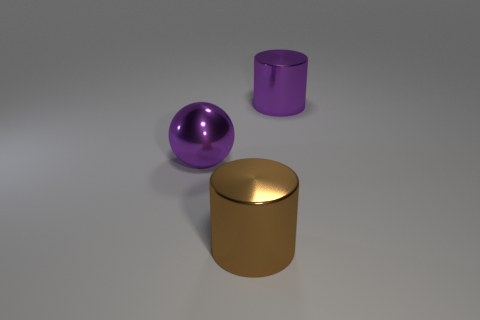What number of brown metal things have the same size as the shiny sphere?
Provide a succinct answer. 1. The large purple object that is made of the same material as the purple cylinder is what shape?
Your response must be concise. Sphere. Are there any metal cylinders of the same color as the sphere?
Your answer should be compact. Yes. What is the brown thing made of?
Provide a succinct answer. Metal. What number of things are either large purple metal balls or purple shiny cylinders?
Ensure brevity in your answer.  2. There is a thing that is in front of the large ball; what is its size?
Make the answer very short. Large. What number of other things are the same material as the big sphere?
Ensure brevity in your answer.  2. There is a metal object in front of the purple shiny ball; is there a big metal cylinder left of it?
Provide a short and direct response. No. Are there any other things that are the same shape as the big brown metal thing?
Your answer should be very brief. Yes. The other thing that is the same shape as the brown thing is what color?
Make the answer very short. Purple. 